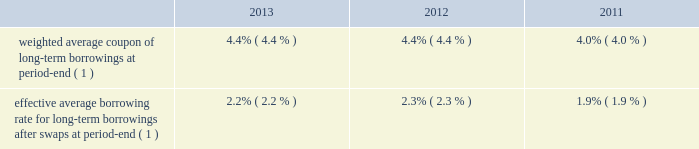Morgan stanley notes to consolidated financial statements 2014 ( continued ) consumer price index ) .
Senior debt also may be structured to be callable by the company or extendible at the option of holders of the senior debt securities .
Debt containing provisions that effectively allow the holders to put or extend the notes aggregated $ 1175 million at december 31 , 2013 and $ 1131 million at december 31 , 2012 .
In addition , separate agreements are entered into by the company 2019s subsidiaries that effectively allow the holders to put the notes aggregated $ 353 million at december 31 , 2013 and $ 1895 million at december 31 , 2012 .
Subordinated debt and junior subordinated debentures generally are issued to meet the capital requirements of the company or its regulated subsidiaries and primarily are u.s .
Dollar denominated .
Senior debt 2014structured borrowings .
The company 2019s index-linked , equity-linked or credit-linked borrowings include various structured instruments whose payments and redemption values are linked to the performance of a specific index ( e.g. , standard & poor 2019s 500 ) , a basket of stocks , a specific equity security , a credit exposure or basket of credit exposures .
To minimize the exposure resulting from movements in the underlying index , equity , credit or other position , the company has entered into various swap contracts and purchased options that effectively convert the borrowing costs into floating rates based upon libor .
These instruments are included in the preceding table at their redemption values based on the performance of the underlying indices , baskets of stocks , or specific equity securities , credit or other position or index .
The company carries either the entire structured borrowing at fair value or bifurcates the embedded derivative and carries it at fair value .
The swaps and purchased options used to economically hedge the embedded features are derivatives and also are carried at fair value .
Changes in fair value related to the notes and economic hedges are reported in trading revenues .
See note 4 for further information on structured borrowings .
Subordinated debt and junior subordinated debentures .
Included in the company 2019s long-term borrowings are subordinated notes of $ 9275 million having a contractual weighted average coupon of 4.69% ( 4.69 % ) at december 31 , 2013 and $ 5845 million having a weighted average coupon of 4.81% ( 4.81 % ) at december 31 , 2012 .
Junior subordinated debentures outstanding by the company were $ 4849 million at december 31 , 2013 and $ 4827 million at december 31 , 2012 having a contractual weighted average coupon of 6.37% ( 6.37 % ) at both december 31 , 2013 and december 31 , 2012 .
Maturities of the subordinated and junior subordinated notes range from 2014 to 2067 .
Maturities of certain junior subordinated debentures can be extended to 2052 at the company 2019s option .
Asset and liability management .
In general , securities inventories that are not financed by secured funding sources and the majority of the company 2019s assets are financed with a combination of deposits , short-term funding , floating rate long-term debt or fixed rate long-term debt swapped to a floating rate .
Fixed assets are generally financed with fixed rate long-term debt .
The company uses interest rate swaps to more closely match these borrowings to the duration , holding period and interest rate characteristics of the assets being funded and to manage interest rate risk .
These swaps effectively convert certain of the company 2019s fixed rate borrowings into floating rate obligations .
In addition , for non-u.s .
Dollar currency borrowings that are not used to fund assets in the same currency , the company has entered into currency swaps that effectively convert the borrowings into u.s .
Dollar obligations .
The company 2019s use of swaps for asset and liability management affected its effective average borrowing rate as follows: .
( 1 ) included in the weighted average and effective average calculations are non-u.s .
Dollar interest rates .
Other .
The company , through several of its subsidiaries , maintains funded and unfunded committed credit facilities to support various businesses , including the collateralized commercial and residential mortgage whole loan , derivative contracts , warehouse lending , emerging market loan , structured product , corporate loan , investment banking and prime brokerage businesses. .
What was the effect in difference of average borrowing rate due to the use of swaps in 2013? 
Computations: (4.4 - 2.2)
Answer: 2.2. 